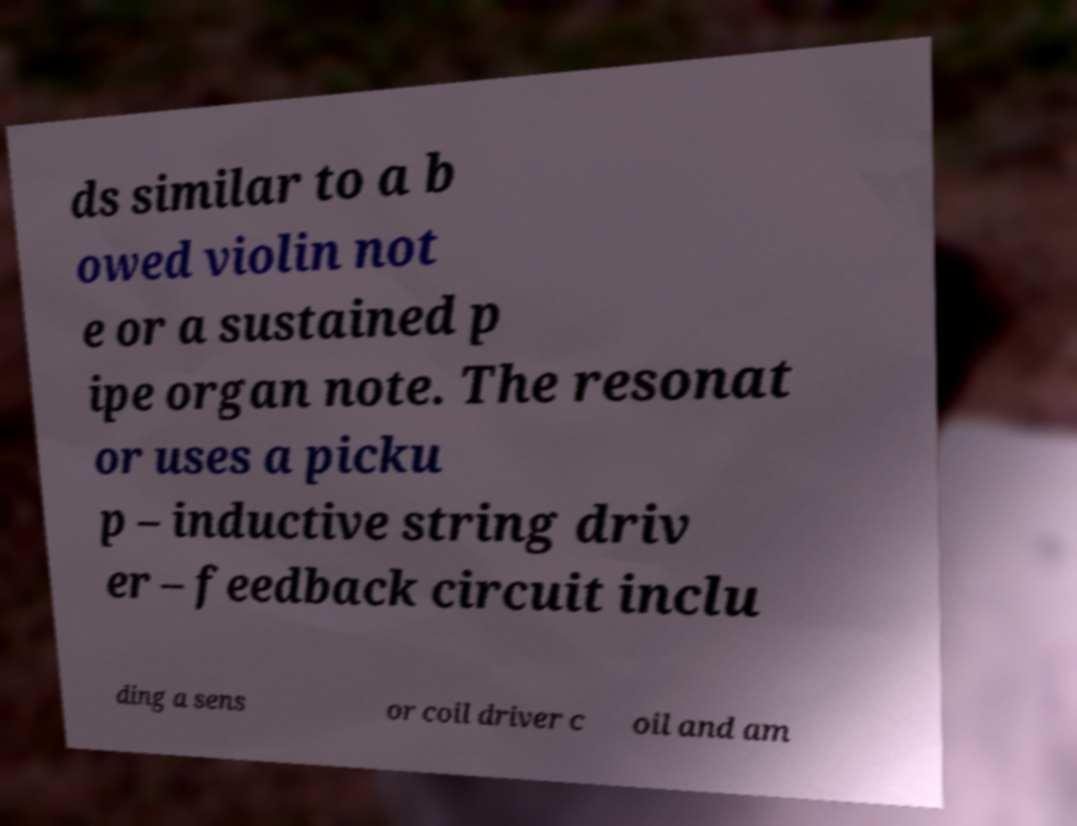There's text embedded in this image that I need extracted. Can you transcribe it verbatim? ds similar to a b owed violin not e or a sustained p ipe organ note. The resonat or uses a picku p – inductive string driv er – feedback circuit inclu ding a sens or coil driver c oil and am 